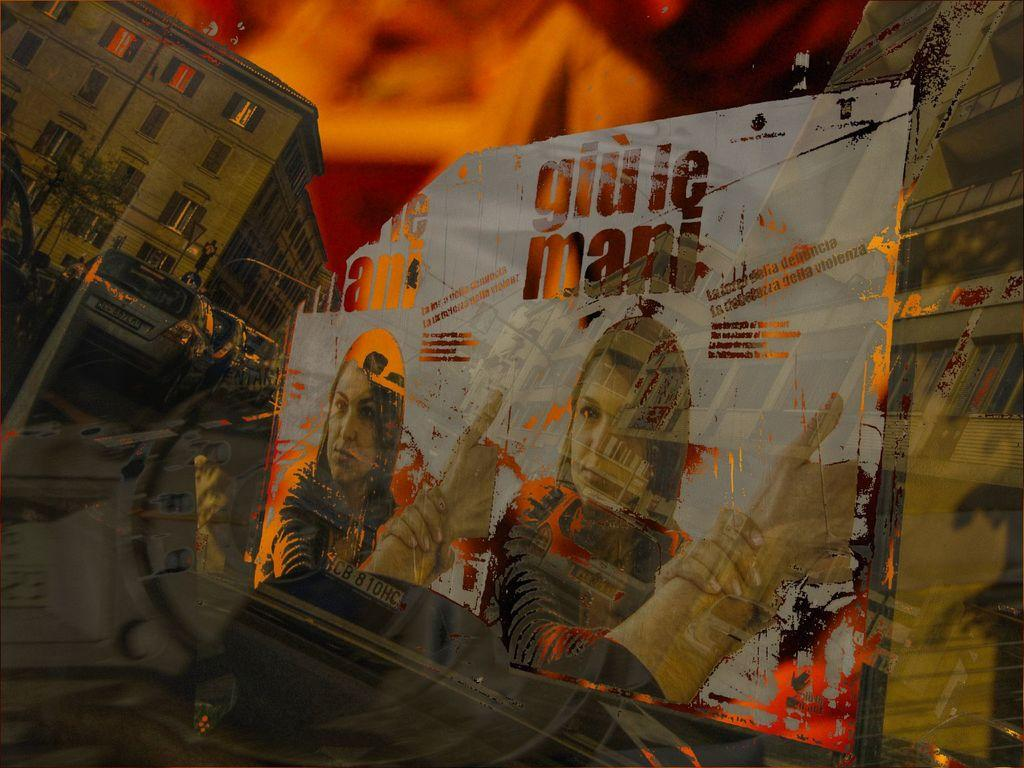What is depicted on the poster in the image? There is a poster with images of persons in the image. What else can be found on the poster besides the images? There is text on the poster. What type of structures can be seen in the image? There are buildings visible in the image. What architectural features are present in the image? There are windows in the image. What else can be seen moving in the image? There are vehicles in the image. What is the dominant color in the background of the image? The background color of the image is red. What time is displayed on the clock in the image? There is no clock present in the image; the conversation focuses on the poster, buildings, windows, vehicles, and the red background. 